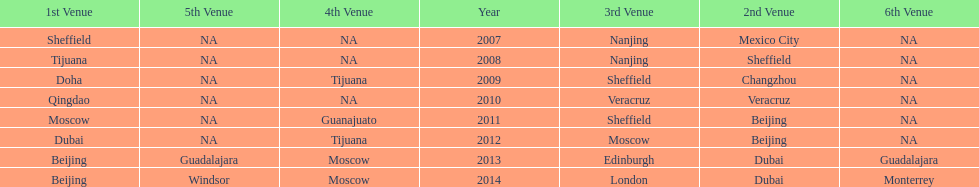What was the last year where tijuana was a venue? 2012. 